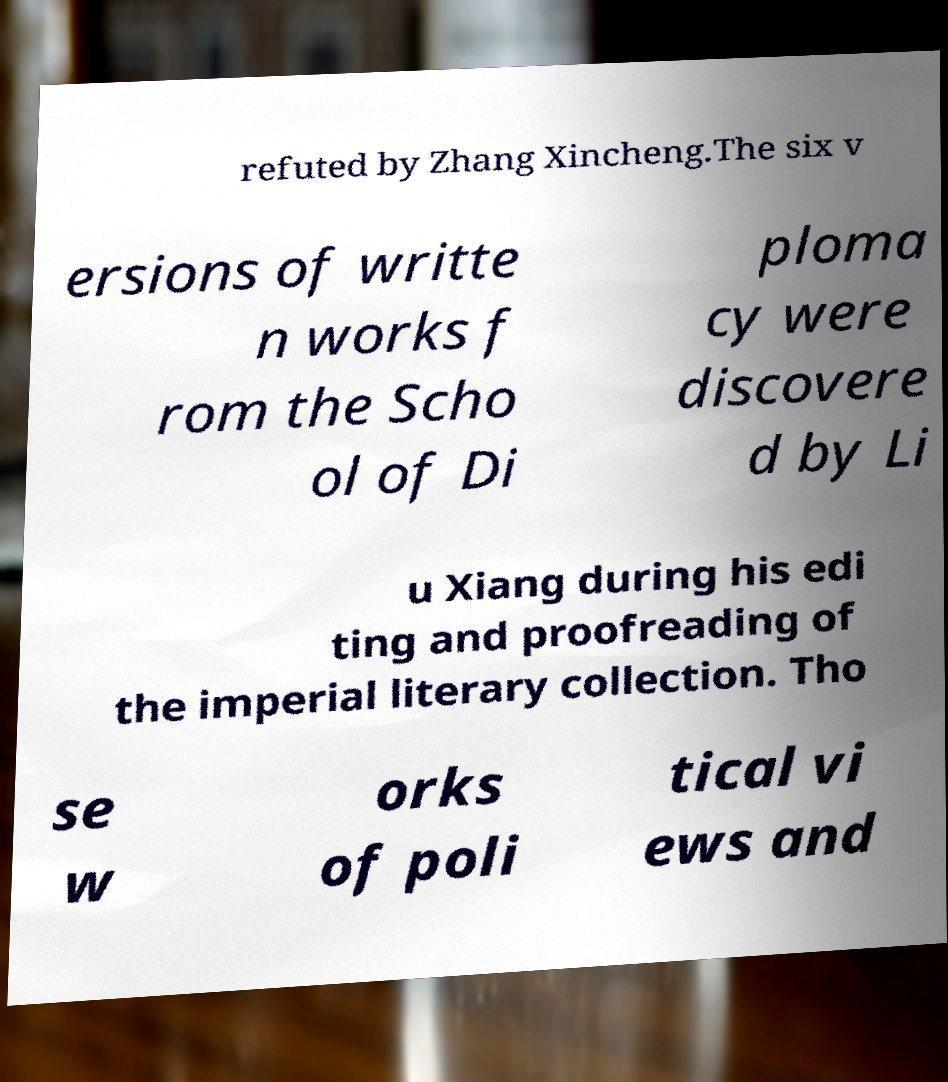What messages or text are displayed in this image? I need them in a readable, typed format. refuted by Zhang Xincheng.The six v ersions of writte n works f rom the Scho ol of Di ploma cy were discovere d by Li u Xiang during his edi ting and proofreading of the imperial literary collection. Tho se w orks of poli tical vi ews and 